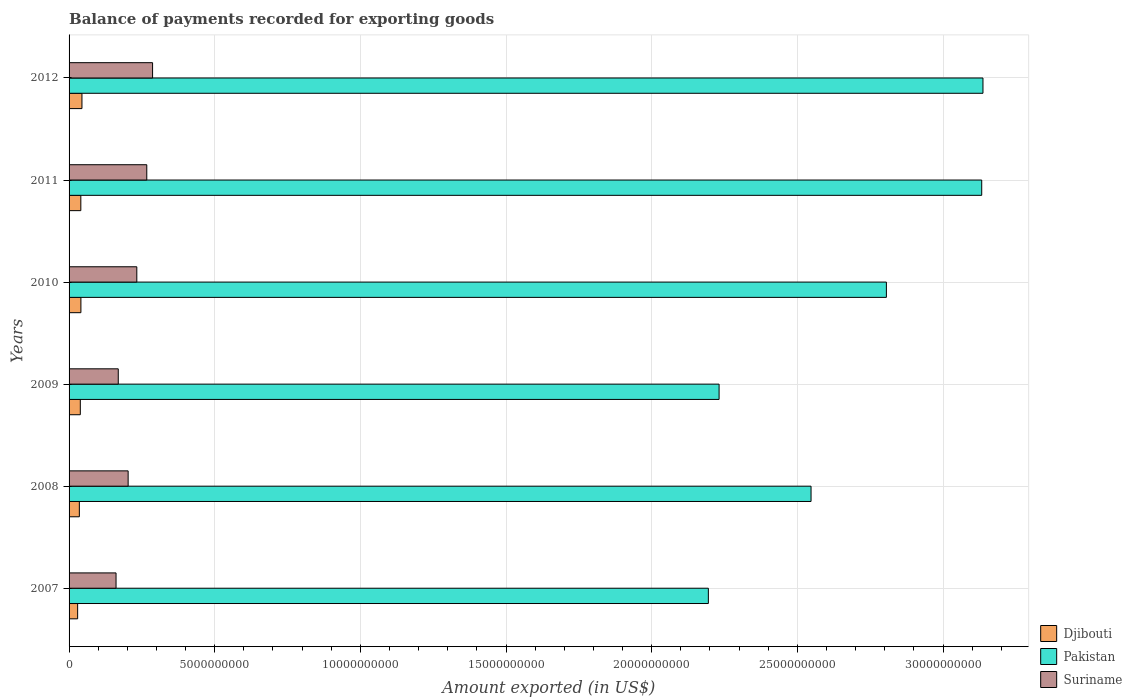What is the label of the 5th group of bars from the top?
Offer a very short reply. 2008. In how many cases, is the number of bars for a given year not equal to the number of legend labels?
Give a very brief answer. 0. What is the amount exported in Suriname in 2012?
Ensure brevity in your answer.  2.87e+09. Across all years, what is the maximum amount exported in Pakistan?
Provide a succinct answer. 3.14e+1. Across all years, what is the minimum amount exported in Djibouti?
Make the answer very short. 2.94e+08. What is the total amount exported in Pakistan in the graph?
Offer a terse response. 1.60e+11. What is the difference between the amount exported in Suriname in 2009 and that in 2012?
Offer a terse response. -1.18e+09. What is the difference between the amount exported in Pakistan in 2008 and the amount exported in Djibouti in 2007?
Offer a terse response. 2.52e+1. What is the average amount exported in Djibouti per year?
Make the answer very short. 3.81e+08. In the year 2010, what is the difference between the amount exported in Djibouti and amount exported in Suriname?
Keep it short and to the point. -1.92e+09. In how many years, is the amount exported in Djibouti greater than 21000000000 US$?
Your answer should be very brief. 0. What is the ratio of the amount exported in Suriname in 2009 to that in 2010?
Provide a succinct answer. 0.73. Is the amount exported in Djibouti in 2009 less than that in 2011?
Offer a very short reply. Yes. Is the difference between the amount exported in Djibouti in 2007 and 2012 greater than the difference between the amount exported in Suriname in 2007 and 2012?
Keep it short and to the point. Yes. What is the difference between the highest and the second highest amount exported in Suriname?
Offer a terse response. 1.99e+08. What is the difference between the highest and the lowest amount exported in Djibouti?
Provide a short and direct response. 1.48e+08. Is the sum of the amount exported in Suriname in 2007 and 2010 greater than the maximum amount exported in Pakistan across all years?
Give a very brief answer. No. What does the 1st bar from the top in 2012 represents?
Offer a very short reply. Suriname. What does the 2nd bar from the bottom in 2009 represents?
Your answer should be compact. Pakistan. How many years are there in the graph?
Provide a succinct answer. 6. What is the difference between two consecutive major ticks on the X-axis?
Ensure brevity in your answer.  5.00e+09. Does the graph contain grids?
Provide a succinct answer. Yes. How are the legend labels stacked?
Keep it short and to the point. Vertical. What is the title of the graph?
Offer a very short reply. Balance of payments recorded for exporting goods. Does "Nigeria" appear as one of the legend labels in the graph?
Ensure brevity in your answer.  No. What is the label or title of the X-axis?
Ensure brevity in your answer.  Amount exported (in US$). What is the label or title of the Y-axis?
Ensure brevity in your answer.  Years. What is the Amount exported (in US$) in Djibouti in 2007?
Give a very brief answer. 2.94e+08. What is the Amount exported (in US$) of Pakistan in 2007?
Ensure brevity in your answer.  2.19e+1. What is the Amount exported (in US$) in Suriname in 2007?
Make the answer very short. 1.61e+09. What is the Amount exported (in US$) of Djibouti in 2008?
Ensure brevity in your answer.  3.53e+08. What is the Amount exported (in US$) in Pakistan in 2008?
Make the answer very short. 2.55e+1. What is the Amount exported (in US$) of Suriname in 2008?
Offer a very short reply. 2.03e+09. What is the Amount exported (in US$) in Djibouti in 2009?
Give a very brief answer. 3.86e+08. What is the Amount exported (in US$) in Pakistan in 2009?
Your answer should be compact. 2.23e+1. What is the Amount exported (in US$) of Suriname in 2009?
Your response must be concise. 1.69e+09. What is the Amount exported (in US$) in Djibouti in 2010?
Your response must be concise. 4.06e+08. What is the Amount exported (in US$) in Pakistan in 2010?
Make the answer very short. 2.81e+1. What is the Amount exported (in US$) in Suriname in 2010?
Ensure brevity in your answer.  2.33e+09. What is the Amount exported (in US$) of Djibouti in 2011?
Ensure brevity in your answer.  4.04e+08. What is the Amount exported (in US$) of Pakistan in 2011?
Provide a succinct answer. 3.13e+1. What is the Amount exported (in US$) of Suriname in 2011?
Provide a short and direct response. 2.67e+09. What is the Amount exported (in US$) of Djibouti in 2012?
Keep it short and to the point. 4.42e+08. What is the Amount exported (in US$) in Pakistan in 2012?
Your answer should be very brief. 3.14e+1. What is the Amount exported (in US$) of Suriname in 2012?
Ensure brevity in your answer.  2.87e+09. Across all years, what is the maximum Amount exported (in US$) of Djibouti?
Keep it short and to the point. 4.42e+08. Across all years, what is the maximum Amount exported (in US$) in Pakistan?
Offer a very short reply. 3.14e+1. Across all years, what is the maximum Amount exported (in US$) of Suriname?
Give a very brief answer. 2.87e+09. Across all years, what is the minimum Amount exported (in US$) in Djibouti?
Your answer should be compact. 2.94e+08. Across all years, what is the minimum Amount exported (in US$) of Pakistan?
Your answer should be very brief. 2.19e+1. Across all years, what is the minimum Amount exported (in US$) of Suriname?
Provide a succinct answer. 1.61e+09. What is the total Amount exported (in US$) of Djibouti in the graph?
Offer a very short reply. 2.28e+09. What is the total Amount exported (in US$) in Pakistan in the graph?
Your response must be concise. 1.60e+11. What is the total Amount exported (in US$) in Suriname in the graph?
Provide a succinct answer. 1.32e+1. What is the difference between the Amount exported (in US$) of Djibouti in 2007 and that in 2008?
Provide a succinct answer. -5.85e+07. What is the difference between the Amount exported (in US$) in Pakistan in 2007 and that in 2008?
Offer a terse response. -3.53e+09. What is the difference between the Amount exported (in US$) in Suriname in 2007 and that in 2008?
Your answer should be very brief. -4.15e+08. What is the difference between the Amount exported (in US$) of Djibouti in 2007 and that in 2009?
Your answer should be compact. -9.16e+07. What is the difference between the Amount exported (in US$) of Pakistan in 2007 and that in 2009?
Keep it short and to the point. -3.69e+08. What is the difference between the Amount exported (in US$) in Suriname in 2007 and that in 2009?
Keep it short and to the point. -7.61e+07. What is the difference between the Amount exported (in US$) of Djibouti in 2007 and that in 2010?
Keep it short and to the point. -1.12e+08. What is the difference between the Amount exported (in US$) of Pakistan in 2007 and that in 2010?
Give a very brief answer. -6.11e+09. What is the difference between the Amount exported (in US$) in Suriname in 2007 and that in 2010?
Provide a succinct answer. -7.13e+08. What is the difference between the Amount exported (in US$) in Djibouti in 2007 and that in 2011?
Offer a terse response. -1.09e+08. What is the difference between the Amount exported (in US$) in Pakistan in 2007 and that in 2011?
Offer a very short reply. -9.38e+09. What is the difference between the Amount exported (in US$) of Suriname in 2007 and that in 2011?
Give a very brief answer. -1.06e+09. What is the difference between the Amount exported (in US$) in Djibouti in 2007 and that in 2012?
Provide a succinct answer. -1.48e+08. What is the difference between the Amount exported (in US$) of Pakistan in 2007 and that in 2012?
Your answer should be very brief. -9.43e+09. What is the difference between the Amount exported (in US$) in Suriname in 2007 and that in 2012?
Your answer should be very brief. -1.25e+09. What is the difference between the Amount exported (in US$) of Djibouti in 2008 and that in 2009?
Provide a short and direct response. -3.31e+07. What is the difference between the Amount exported (in US$) in Pakistan in 2008 and that in 2009?
Keep it short and to the point. 3.16e+09. What is the difference between the Amount exported (in US$) in Suriname in 2008 and that in 2009?
Provide a succinct answer. 3.39e+08. What is the difference between the Amount exported (in US$) of Djibouti in 2008 and that in 2010?
Provide a succinct answer. -5.36e+07. What is the difference between the Amount exported (in US$) of Pakistan in 2008 and that in 2010?
Your response must be concise. -2.59e+09. What is the difference between the Amount exported (in US$) in Suriname in 2008 and that in 2010?
Your answer should be very brief. -2.98e+08. What is the difference between the Amount exported (in US$) in Djibouti in 2008 and that in 2011?
Your response must be concise. -5.09e+07. What is the difference between the Amount exported (in US$) of Pakistan in 2008 and that in 2011?
Make the answer very short. -5.86e+09. What is the difference between the Amount exported (in US$) of Suriname in 2008 and that in 2011?
Keep it short and to the point. -6.40e+08. What is the difference between the Amount exported (in US$) of Djibouti in 2008 and that in 2012?
Give a very brief answer. -8.93e+07. What is the difference between the Amount exported (in US$) in Pakistan in 2008 and that in 2012?
Provide a short and direct response. -5.90e+09. What is the difference between the Amount exported (in US$) in Suriname in 2008 and that in 2012?
Your answer should be compact. -8.39e+08. What is the difference between the Amount exported (in US$) in Djibouti in 2009 and that in 2010?
Your answer should be very brief. -2.05e+07. What is the difference between the Amount exported (in US$) of Pakistan in 2009 and that in 2010?
Keep it short and to the point. -5.74e+09. What is the difference between the Amount exported (in US$) in Suriname in 2009 and that in 2010?
Your response must be concise. -6.37e+08. What is the difference between the Amount exported (in US$) in Djibouti in 2009 and that in 2011?
Offer a terse response. -1.78e+07. What is the difference between the Amount exported (in US$) in Pakistan in 2009 and that in 2011?
Ensure brevity in your answer.  -9.02e+09. What is the difference between the Amount exported (in US$) of Suriname in 2009 and that in 2011?
Give a very brief answer. -9.79e+08. What is the difference between the Amount exported (in US$) in Djibouti in 2009 and that in 2012?
Ensure brevity in your answer.  -5.63e+07. What is the difference between the Amount exported (in US$) of Pakistan in 2009 and that in 2012?
Your response must be concise. -9.06e+09. What is the difference between the Amount exported (in US$) in Suriname in 2009 and that in 2012?
Your answer should be compact. -1.18e+09. What is the difference between the Amount exported (in US$) in Djibouti in 2010 and that in 2011?
Your answer should be very brief. 2.64e+06. What is the difference between the Amount exported (in US$) in Pakistan in 2010 and that in 2011?
Offer a terse response. -3.27e+09. What is the difference between the Amount exported (in US$) of Suriname in 2010 and that in 2011?
Ensure brevity in your answer.  -3.42e+08. What is the difference between the Amount exported (in US$) in Djibouti in 2010 and that in 2012?
Give a very brief answer. -3.58e+07. What is the difference between the Amount exported (in US$) in Pakistan in 2010 and that in 2012?
Your answer should be compact. -3.32e+09. What is the difference between the Amount exported (in US$) in Suriname in 2010 and that in 2012?
Offer a very short reply. -5.41e+08. What is the difference between the Amount exported (in US$) of Djibouti in 2011 and that in 2012?
Provide a succinct answer. -3.84e+07. What is the difference between the Amount exported (in US$) in Pakistan in 2011 and that in 2012?
Provide a short and direct response. -4.27e+07. What is the difference between the Amount exported (in US$) in Suriname in 2011 and that in 2012?
Your answer should be very brief. -1.99e+08. What is the difference between the Amount exported (in US$) of Djibouti in 2007 and the Amount exported (in US$) of Pakistan in 2008?
Provide a short and direct response. -2.52e+1. What is the difference between the Amount exported (in US$) of Djibouti in 2007 and the Amount exported (in US$) of Suriname in 2008?
Give a very brief answer. -1.73e+09. What is the difference between the Amount exported (in US$) in Pakistan in 2007 and the Amount exported (in US$) in Suriname in 2008?
Make the answer very short. 1.99e+1. What is the difference between the Amount exported (in US$) in Djibouti in 2007 and the Amount exported (in US$) in Pakistan in 2009?
Offer a very short reply. -2.20e+1. What is the difference between the Amount exported (in US$) of Djibouti in 2007 and the Amount exported (in US$) of Suriname in 2009?
Offer a very short reply. -1.39e+09. What is the difference between the Amount exported (in US$) in Pakistan in 2007 and the Amount exported (in US$) in Suriname in 2009?
Offer a terse response. 2.03e+1. What is the difference between the Amount exported (in US$) in Djibouti in 2007 and the Amount exported (in US$) in Pakistan in 2010?
Give a very brief answer. -2.78e+1. What is the difference between the Amount exported (in US$) of Djibouti in 2007 and the Amount exported (in US$) of Suriname in 2010?
Provide a succinct answer. -2.03e+09. What is the difference between the Amount exported (in US$) in Pakistan in 2007 and the Amount exported (in US$) in Suriname in 2010?
Offer a very short reply. 1.96e+1. What is the difference between the Amount exported (in US$) in Djibouti in 2007 and the Amount exported (in US$) in Pakistan in 2011?
Provide a short and direct response. -3.10e+1. What is the difference between the Amount exported (in US$) in Djibouti in 2007 and the Amount exported (in US$) in Suriname in 2011?
Your answer should be very brief. -2.37e+09. What is the difference between the Amount exported (in US$) in Pakistan in 2007 and the Amount exported (in US$) in Suriname in 2011?
Give a very brief answer. 1.93e+1. What is the difference between the Amount exported (in US$) in Djibouti in 2007 and the Amount exported (in US$) in Pakistan in 2012?
Your answer should be compact. -3.11e+1. What is the difference between the Amount exported (in US$) in Djibouti in 2007 and the Amount exported (in US$) in Suriname in 2012?
Provide a short and direct response. -2.57e+09. What is the difference between the Amount exported (in US$) of Pakistan in 2007 and the Amount exported (in US$) of Suriname in 2012?
Ensure brevity in your answer.  1.91e+1. What is the difference between the Amount exported (in US$) in Djibouti in 2008 and the Amount exported (in US$) in Pakistan in 2009?
Provide a succinct answer. -2.20e+1. What is the difference between the Amount exported (in US$) of Djibouti in 2008 and the Amount exported (in US$) of Suriname in 2009?
Keep it short and to the point. -1.34e+09. What is the difference between the Amount exported (in US$) of Pakistan in 2008 and the Amount exported (in US$) of Suriname in 2009?
Give a very brief answer. 2.38e+1. What is the difference between the Amount exported (in US$) of Djibouti in 2008 and the Amount exported (in US$) of Pakistan in 2010?
Give a very brief answer. -2.77e+1. What is the difference between the Amount exported (in US$) in Djibouti in 2008 and the Amount exported (in US$) in Suriname in 2010?
Offer a very short reply. -1.97e+09. What is the difference between the Amount exported (in US$) of Pakistan in 2008 and the Amount exported (in US$) of Suriname in 2010?
Your answer should be compact. 2.31e+1. What is the difference between the Amount exported (in US$) in Djibouti in 2008 and the Amount exported (in US$) in Pakistan in 2011?
Give a very brief answer. -3.10e+1. What is the difference between the Amount exported (in US$) in Djibouti in 2008 and the Amount exported (in US$) in Suriname in 2011?
Your response must be concise. -2.31e+09. What is the difference between the Amount exported (in US$) in Pakistan in 2008 and the Amount exported (in US$) in Suriname in 2011?
Keep it short and to the point. 2.28e+1. What is the difference between the Amount exported (in US$) of Djibouti in 2008 and the Amount exported (in US$) of Pakistan in 2012?
Ensure brevity in your answer.  -3.10e+1. What is the difference between the Amount exported (in US$) in Djibouti in 2008 and the Amount exported (in US$) in Suriname in 2012?
Provide a succinct answer. -2.51e+09. What is the difference between the Amount exported (in US$) of Pakistan in 2008 and the Amount exported (in US$) of Suriname in 2012?
Provide a succinct answer. 2.26e+1. What is the difference between the Amount exported (in US$) of Djibouti in 2009 and the Amount exported (in US$) of Pakistan in 2010?
Give a very brief answer. -2.77e+1. What is the difference between the Amount exported (in US$) of Djibouti in 2009 and the Amount exported (in US$) of Suriname in 2010?
Make the answer very short. -1.94e+09. What is the difference between the Amount exported (in US$) in Pakistan in 2009 and the Amount exported (in US$) in Suriname in 2010?
Provide a short and direct response. 2.00e+1. What is the difference between the Amount exported (in US$) of Djibouti in 2009 and the Amount exported (in US$) of Pakistan in 2011?
Ensure brevity in your answer.  -3.09e+1. What is the difference between the Amount exported (in US$) in Djibouti in 2009 and the Amount exported (in US$) in Suriname in 2011?
Offer a very short reply. -2.28e+09. What is the difference between the Amount exported (in US$) of Pakistan in 2009 and the Amount exported (in US$) of Suriname in 2011?
Provide a succinct answer. 1.96e+1. What is the difference between the Amount exported (in US$) in Djibouti in 2009 and the Amount exported (in US$) in Pakistan in 2012?
Provide a succinct answer. -3.10e+1. What is the difference between the Amount exported (in US$) of Djibouti in 2009 and the Amount exported (in US$) of Suriname in 2012?
Provide a short and direct response. -2.48e+09. What is the difference between the Amount exported (in US$) of Pakistan in 2009 and the Amount exported (in US$) of Suriname in 2012?
Offer a very short reply. 1.94e+1. What is the difference between the Amount exported (in US$) in Djibouti in 2010 and the Amount exported (in US$) in Pakistan in 2011?
Your answer should be compact. -3.09e+1. What is the difference between the Amount exported (in US$) of Djibouti in 2010 and the Amount exported (in US$) of Suriname in 2011?
Give a very brief answer. -2.26e+09. What is the difference between the Amount exported (in US$) in Pakistan in 2010 and the Amount exported (in US$) in Suriname in 2011?
Provide a succinct answer. 2.54e+1. What is the difference between the Amount exported (in US$) in Djibouti in 2010 and the Amount exported (in US$) in Pakistan in 2012?
Your answer should be very brief. -3.10e+1. What is the difference between the Amount exported (in US$) in Djibouti in 2010 and the Amount exported (in US$) in Suriname in 2012?
Make the answer very short. -2.46e+09. What is the difference between the Amount exported (in US$) of Pakistan in 2010 and the Amount exported (in US$) of Suriname in 2012?
Your answer should be very brief. 2.52e+1. What is the difference between the Amount exported (in US$) of Djibouti in 2011 and the Amount exported (in US$) of Pakistan in 2012?
Your answer should be compact. -3.10e+1. What is the difference between the Amount exported (in US$) of Djibouti in 2011 and the Amount exported (in US$) of Suriname in 2012?
Provide a succinct answer. -2.46e+09. What is the difference between the Amount exported (in US$) of Pakistan in 2011 and the Amount exported (in US$) of Suriname in 2012?
Your answer should be compact. 2.85e+1. What is the average Amount exported (in US$) of Djibouti per year?
Offer a terse response. 3.81e+08. What is the average Amount exported (in US$) in Pakistan per year?
Provide a succinct answer. 2.67e+1. What is the average Amount exported (in US$) in Suriname per year?
Make the answer very short. 2.20e+09. In the year 2007, what is the difference between the Amount exported (in US$) in Djibouti and Amount exported (in US$) in Pakistan?
Provide a succinct answer. -2.17e+1. In the year 2007, what is the difference between the Amount exported (in US$) in Djibouti and Amount exported (in US$) in Suriname?
Ensure brevity in your answer.  -1.32e+09. In the year 2007, what is the difference between the Amount exported (in US$) of Pakistan and Amount exported (in US$) of Suriname?
Offer a terse response. 2.03e+1. In the year 2008, what is the difference between the Amount exported (in US$) in Djibouti and Amount exported (in US$) in Pakistan?
Keep it short and to the point. -2.51e+1. In the year 2008, what is the difference between the Amount exported (in US$) of Djibouti and Amount exported (in US$) of Suriname?
Your answer should be very brief. -1.67e+09. In the year 2008, what is the difference between the Amount exported (in US$) of Pakistan and Amount exported (in US$) of Suriname?
Keep it short and to the point. 2.34e+1. In the year 2009, what is the difference between the Amount exported (in US$) of Djibouti and Amount exported (in US$) of Pakistan?
Make the answer very short. -2.19e+1. In the year 2009, what is the difference between the Amount exported (in US$) in Djibouti and Amount exported (in US$) in Suriname?
Your response must be concise. -1.30e+09. In the year 2009, what is the difference between the Amount exported (in US$) of Pakistan and Amount exported (in US$) of Suriname?
Give a very brief answer. 2.06e+1. In the year 2010, what is the difference between the Amount exported (in US$) of Djibouti and Amount exported (in US$) of Pakistan?
Your answer should be very brief. -2.77e+1. In the year 2010, what is the difference between the Amount exported (in US$) in Djibouti and Amount exported (in US$) in Suriname?
Offer a terse response. -1.92e+09. In the year 2010, what is the difference between the Amount exported (in US$) in Pakistan and Amount exported (in US$) in Suriname?
Make the answer very short. 2.57e+1. In the year 2011, what is the difference between the Amount exported (in US$) of Djibouti and Amount exported (in US$) of Pakistan?
Your answer should be compact. -3.09e+1. In the year 2011, what is the difference between the Amount exported (in US$) of Djibouti and Amount exported (in US$) of Suriname?
Provide a succinct answer. -2.26e+09. In the year 2011, what is the difference between the Amount exported (in US$) in Pakistan and Amount exported (in US$) in Suriname?
Your response must be concise. 2.87e+1. In the year 2012, what is the difference between the Amount exported (in US$) of Djibouti and Amount exported (in US$) of Pakistan?
Provide a short and direct response. -3.09e+1. In the year 2012, what is the difference between the Amount exported (in US$) of Djibouti and Amount exported (in US$) of Suriname?
Ensure brevity in your answer.  -2.42e+09. In the year 2012, what is the difference between the Amount exported (in US$) in Pakistan and Amount exported (in US$) in Suriname?
Provide a short and direct response. 2.85e+1. What is the ratio of the Amount exported (in US$) of Djibouti in 2007 to that in 2008?
Provide a succinct answer. 0.83. What is the ratio of the Amount exported (in US$) of Pakistan in 2007 to that in 2008?
Your answer should be compact. 0.86. What is the ratio of the Amount exported (in US$) in Suriname in 2007 to that in 2008?
Give a very brief answer. 0.8. What is the ratio of the Amount exported (in US$) of Djibouti in 2007 to that in 2009?
Provide a short and direct response. 0.76. What is the ratio of the Amount exported (in US$) of Pakistan in 2007 to that in 2009?
Offer a very short reply. 0.98. What is the ratio of the Amount exported (in US$) of Suriname in 2007 to that in 2009?
Ensure brevity in your answer.  0.95. What is the ratio of the Amount exported (in US$) of Djibouti in 2007 to that in 2010?
Provide a succinct answer. 0.72. What is the ratio of the Amount exported (in US$) in Pakistan in 2007 to that in 2010?
Your answer should be very brief. 0.78. What is the ratio of the Amount exported (in US$) of Suriname in 2007 to that in 2010?
Ensure brevity in your answer.  0.69. What is the ratio of the Amount exported (in US$) of Djibouti in 2007 to that in 2011?
Your answer should be very brief. 0.73. What is the ratio of the Amount exported (in US$) in Pakistan in 2007 to that in 2011?
Your answer should be very brief. 0.7. What is the ratio of the Amount exported (in US$) in Suriname in 2007 to that in 2011?
Offer a terse response. 0.6. What is the ratio of the Amount exported (in US$) of Djibouti in 2007 to that in 2012?
Give a very brief answer. 0.67. What is the ratio of the Amount exported (in US$) of Pakistan in 2007 to that in 2012?
Your answer should be compact. 0.7. What is the ratio of the Amount exported (in US$) of Suriname in 2007 to that in 2012?
Your response must be concise. 0.56. What is the ratio of the Amount exported (in US$) in Djibouti in 2008 to that in 2009?
Offer a very short reply. 0.91. What is the ratio of the Amount exported (in US$) of Pakistan in 2008 to that in 2009?
Offer a very short reply. 1.14. What is the ratio of the Amount exported (in US$) in Suriname in 2008 to that in 2009?
Offer a terse response. 1.2. What is the ratio of the Amount exported (in US$) in Djibouti in 2008 to that in 2010?
Ensure brevity in your answer.  0.87. What is the ratio of the Amount exported (in US$) in Pakistan in 2008 to that in 2010?
Provide a succinct answer. 0.91. What is the ratio of the Amount exported (in US$) in Suriname in 2008 to that in 2010?
Ensure brevity in your answer.  0.87. What is the ratio of the Amount exported (in US$) of Djibouti in 2008 to that in 2011?
Ensure brevity in your answer.  0.87. What is the ratio of the Amount exported (in US$) of Pakistan in 2008 to that in 2011?
Your answer should be very brief. 0.81. What is the ratio of the Amount exported (in US$) of Suriname in 2008 to that in 2011?
Your response must be concise. 0.76. What is the ratio of the Amount exported (in US$) of Djibouti in 2008 to that in 2012?
Provide a short and direct response. 0.8. What is the ratio of the Amount exported (in US$) in Pakistan in 2008 to that in 2012?
Give a very brief answer. 0.81. What is the ratio of the Amount exported (in US$) of Suriname in 2008 to that in 2012?
Offer a very short reply. 0.71. What is the ratio of the Amount exported (in US$) in Djibouti in 2009 to that in 2010?
Make the answer very short. 0.95. What is the ratio of the Amount exported (in US$) in Pakistan in 2009 to that in 2010?
Your answer should be compact. 0.8. What is the ratio of the Amount exported (in US$) of Suriname in 2009 to that in 2010?
Provide a short and direct response. 0.73. What is the ratio of the Amount exported (in US$) of Djibouti in 2009 to that in 2011?
Your answer should be compact. 0.96. What is the ratio of the Amount exported (in US$) of Pakistan in 2009 to that in 2011?
Offer a terse response. 0.71. What is the ratio of the Amount exported (in US$) in Suriname in 2009 to that in 2011?
Your answer should be very brief. 0.63. What is the ratio of the Amount exported (in US$) in Djibouti in 2009 to that in 2012?
Keep it short and to the point. 0.87. What is the ratio of the Amount exported (in US$) of Pakistan in 2009 to that in 2012?
Keep it short and to the point. 0.71. What is the ratio of the Amount exported (in US$) in Suriname in 2009 to that in 2012?
Your answer should be compact. 0.59. What is the ratio of the Amount exported (in US$) in Pakistan in 2010 to that in 2011?
Your answer should be very brief. 0.9. What is the ratio of the Amount exported (in US$) of Suriname in 2010 to that in 2011?
Offer a terse response. 0.87. What is the ratio of the Amount exported (in US$) of Djibouti in 2010 to that in 2012?
Keep it short and to the point. 0.92. What is the ratio of the Amount exported (in US$) of Pakistan in 2010 to that in 2012?
Provide a succinct answer. 0.89. What is the ratio of the Amount exported (in US$) of Suriname in 2010 to that in 2012?
Keep it short and to the point. 0.81. What is the ratio of the Amount exported (in US$) in Djibouti in 2011 to that in 2012?
Offer a terse response. 0.91. What is the ratio of the Amount exported (in US$) in Suriname in 2011 to that in 2012?
Your response must be concise. 0.93. What is the difference between the highest and the second highest Amount exported (in US$) in Djibouti?
Offer a very short reply. 3.58e+07. What is the difference between the highest and the second highest Amount exported (in US$) of Pakistan?
Ensure brevity in your answer.  4.27e+07. What is the difference between the highest and the second highest Amount exported (in US$) of Suriname?
Ensure brevity in your answer.  1.99e+08. What is the difference between the highest and the lowest Amount exported (in US$) in Djibouti?
Your answer should be very brief. 1.48e+08. What is the difference between the highest and the lowest Amount exported (in US$) of Pakistan?
Your answer should be compact. 9.43e+09. What is the difference between the highest and the lowest Amount exported (in US$) in Suriname?
Offer a terse response. 1.25e+09. 